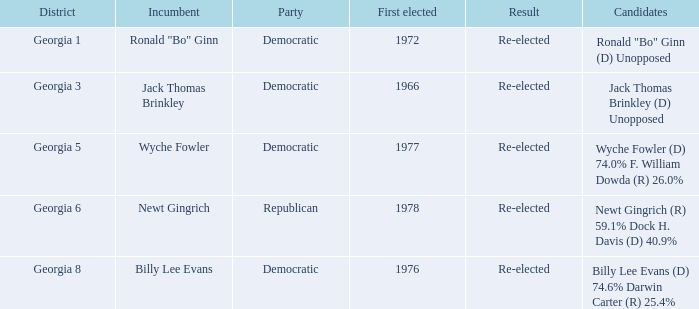How many incumbents were there in the 6th district of georgia? 1.0. Could you parse the entire table? {'header': ['District', 'Incumbent', 'Party', 'First elected', 'Result', 'Candidates'], 'rows': [['Georgia 1', 'Ronald "Bo" Ginn', 'Democratic', '1972', 'Re-elected', 'Ronald "Bo" Ginn (D) Unopposed'], ['Georgia 3', 'Jack Thomas Brinkley', 'Democratic', '1966', 'Re-elected', 'Jack Thomas Brinkley (D) Unopposed'], ['Georgia 5', 'Wyche Fowler', 'Democratic', '1977', 'Re-elected', 'Wyche Fowler (D) 74.0% F. William Dowda (R) 26.0%'], ['Georgia 6', 'Newt Gingrich', 'Republican', '1978', 'Re-elected', 'Newt Gingrich (R) 59.1% Dock H. Davis (D) 40.9%'], ['Georgia 8', 'Billy Lee Evans', 'Democratic', '1976', 'Re-elected', 'Billy Lee Evans (D) 74.6% Darwin Carter (R) 25.4%']]} 